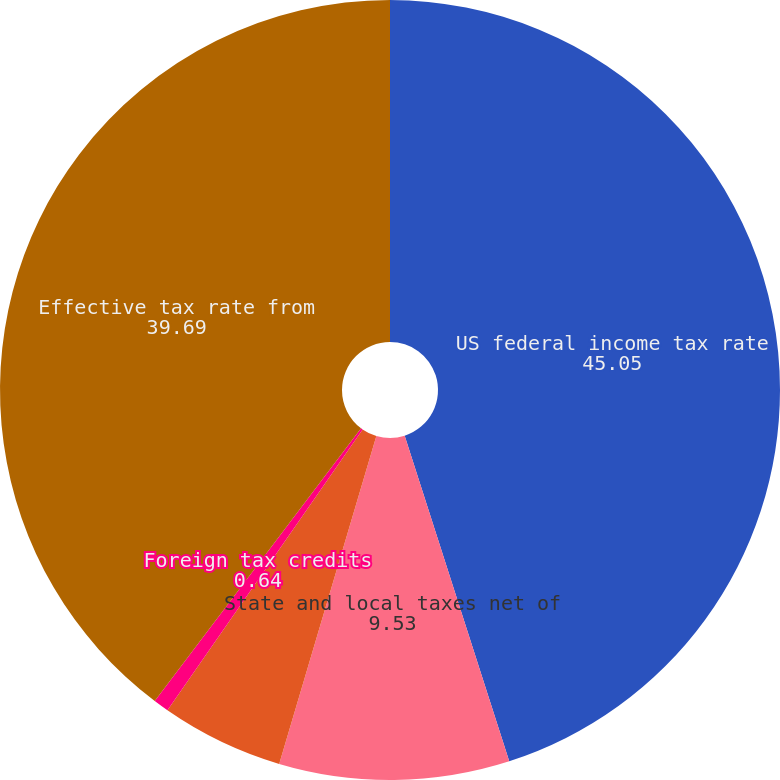<chart> <loc_0><loc_0><loc_500><loc_500><pie_chart><fcel>US federal income tax rate<fcel>State and local taxes net of<fcel>Foreignoperations tax effect<fcel>Foreign tax credits<fcel>Effective tax rate from<nl><fcel>45.05%<fcel>9.53%<fcel>5.08%<fcel>0.64%<fcel>39.69%<nl></chart> 